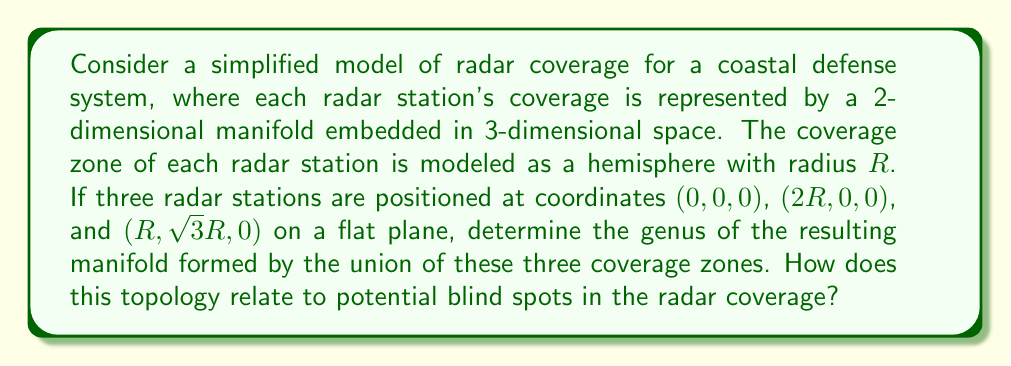Provide a solution to this math problem. To solve this problem, we'll follow these steps:

1) Visualize the setup:
   The three radar stations form an equilateral triangle on the xy-plane, with side length $2R$. Each station's coverage is a hemisphere of radius $R$.

2) Analyze the intersections:
   - Each pair of hemispheres intersects in a circular arc.
   - All three hemispheres intersect at two points.

3) Determine the topology:
   - The union of the three hemispheres forms a single connected surface.
   - There are no holes that go completely through the surface.
   - The surface has a single boundary along the xy-plane.

4) Calculate the genus:
   - The resulting surface is homeomorphic to a disk.
   - A disk has genus 0.

5) Relate to blind spots:
   - The genus 0 surface indicates no complete gaps in coverage within the union of the three zones.
   - However, blind spots may exist:
     a) Below the xy-plane (underground or underwater)
     b) In the corners between the hemispheres, especially near the ground
     c) Beyond the range $R$ of the radars

The genus of 0 tells us that the coverage is simply connected, but doesn't guarantee complete coverage of all points within the triangle formed by the radar stations.
Answer: The genus of the manifold formed by the union of the three radar coverage zones is 0. This topology indicates no complete gaps within the covered area, but potential blind spots may exist in the lower corners between coverage zones and beyond the range of the radars. 